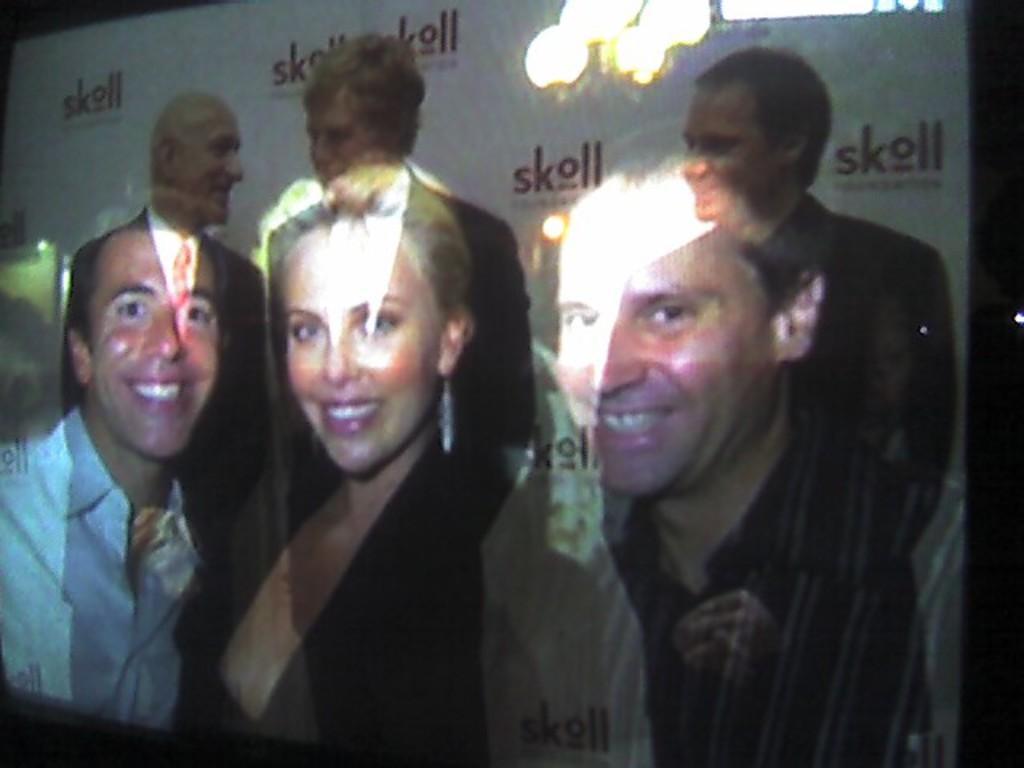How would you summarize this image in a sentence or two? In this image we can see three persons on the screen and reflection of two men and one woman. 